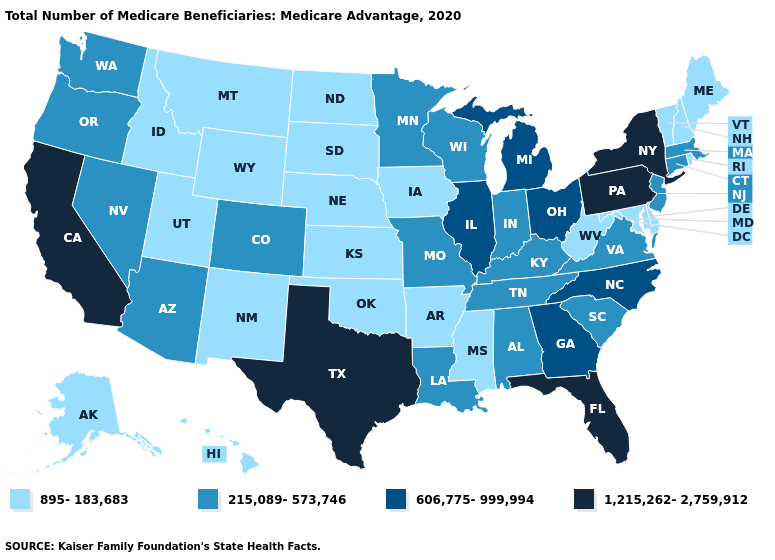Among the states that border South Dakota , which have the lowest value?
Answer briefly. Iowa, Montana, Nebraska, North Dakota, Wyoming. Name the states that have a value in the range 1,215,262-2,759,912?
Give a very brief answer. California, Florida, New York, Pennsylvania, Texas. Does Virginia have a higher value than South Dakota?
Short answer required. Yes. Among the states that border Nebraska , which have the lowest value?
Answer briefly. Iowa, Kansas, South Dakota, Wyoming. Which states have the lowest value in the USA?
Be succinct. Alaska, Arkansas, Delaware, Hawaii, Idaho, Iowa, Kansas, Maine, Maryland, Mississippi, Montana, Nebraska, New Hampshire, New Mexico, North Dakota, Oklahoma, Rhode Island, South Dakota, Utah, Vermont, West Virginia, Wyoming. Does Indiana have the same value as Tennessee?
Write a very short answer. Yes. Name the states that have a value in the range 215,089-573,746?
Keep it brief. Alabama, Arizona, Colorado, Connecticut, Indiana, Kentucky, Louisiana, Massachusetts, Minnesota, Missouri, Nevada, New Jersey, Oregon, South Carolina, Tennessee, Virginia, Washington, Wisconsin. What is the value of Georgia?
Concise answer only. 606,775-999,994. Among the states that border New Jersey , which have the lowest value?
Short answer required. Delaware. Does Michigan have the highest value in the USA?
Concise answer only. No. Which states have the highest value in the USA?
Quick response, please. California, Florida, New York, Pennsylvania, Texas. What is the value of Florida?
Concise answer only. 1,215,262-2,759,912. What is the lowest value in the Northeast?
Write a very short answer. 895-183,683. Name the states that have a value in the range 606,775-999,994?
Keep it brief. Georgia, Illinois, Michigan, North Carolina, Ohio. Which states have the highest value in the USA?
Answer briefly. California, Florida, New York, Pennsylvania, Texas. 